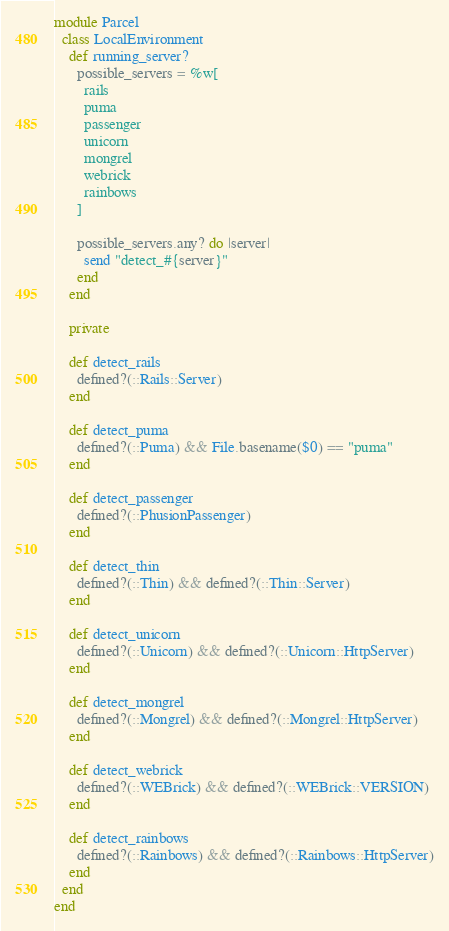<code> <loc_0><loc_0><loc_500><loc_500><_Ruby_>module Parcel
  class LocalEnvironment
    def running_server?
      possible_servers = %w[
        rails
        puma
        passenger
        unicorn
        mongrel
        webrick
        rainbows
      ]

      possible_servers.any? do |server|
        send "detect_#{server}"
      end
    end

    private

    def detect_rails
      defined?(::Rails::Server)
    end

    def detect_puma
      defined?(::Puma) && File.basename($0) == "puma"
    end

    def detect_passenger
      defined?(::PhusionPassenger)
    end

    def detect_thin
      defined?(::Thin) && defined?(::Thin::Server)
    end

    def detect_unicorn
      defined?(::Unicorn) && defined?(::Unicorn::HttpServer)
    end

    def detect_mongrel
      defined?(::Mongrel) && defined?(::Mongrel::HttpServer)
    end

    def detect_webrick
      defined?(::WEBrick) && defined?(::WEBrick::VERSION)
    end

    def detect_rainbows
      defined?(::Rainbows) && defined?(::Rainbows::HttpServer)
    end
  end
end
</code> 